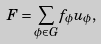Convert formula to latex. <formula><loc_0><loc_0><loc_500><loc_500>F = \sum _ { \phi \in G } f _ { \phi } u _ { \phi } ,</formula> 